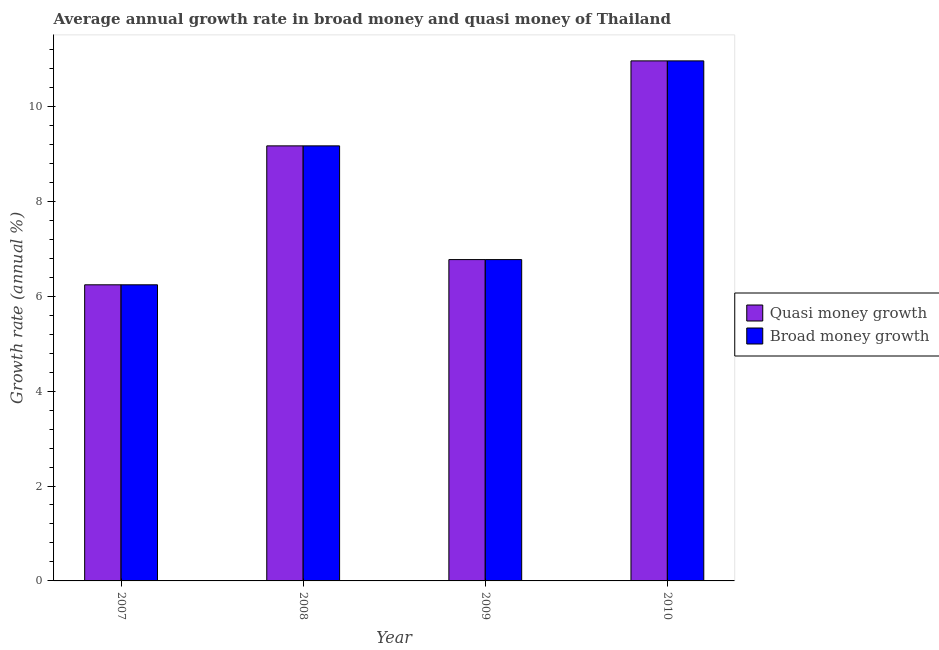How many different coloured bars are there?
Provide a succinct answer. 2. Are the number of bars on each tick of the X-axis equal?
Offer a terse response. Yes. In how many cases, is the number of bars for a given year not equal to the number of legend labels?
Your response must be concise. 0. What is the annual growth rate in broad money in 2008?
Keep it short and to the point. 9.17. Across all years, what is the maximum annual growth rate in quasi money?
Make the answer very short. 10.96. Across all years, what is the minimum annual growth rate in broad money?
Provide a short and direct response. 6.24. In which year was the annual growth rate in quasi money minimum?
Offer a terse response. 2007. What is the total annual growth rate in broad money in the graph?
Keep it short and to the point. 33.14. What is the difference between the annual growth rate in quasi money in 2007 and that in 2009?
Keep it short and to the point. -0.53. What is the difference between the annual growth rate in quasi money in 2008 and the annual growth rate in broad money in 2010?
Offer a terse response. -1.79. What is the average annual growth rate in quasi money per year?
Offer a terse response. 8.28. In the year 2009, what is the difference between the annual growth rate in broad money and annual growth rate in quasi money?
Offer a terse response. 0. In how many years, is the annual growth rate in quasi money greater than 3.6 %?
Offer a terse response. 4. What is the ratio of the annual growth rate in broad money in 2007 to that in 2009?
Keep it short and to the point. 0.92. What is the difference between the highest and the second highest annual growth rate in quasi money?
Offer a very short reply. 1.79. What is the difference between the highest and the lowest annual growth rate in broad money?
Your response must be concise. 4.72. In how many years, is the annual growth rate in quasi money greater than the average annual growth rate in quasi money taken over all years?
Your answer should be very brief. 2. Is the sum of the annual growth rate in quasi money in 2008 and 2010 greater than the maximum annual growth rate in broad money across all years?
Offer a very short reply. Yes. What does the 1st bar from the left in 2007 represents?
Keep it short and to the point. Quasi money growth. What does the 1st bar from the right in 2009 represents?
Your response must be concise. Broad money growth. Are the values on the major ticks of Y-axis written in scientific E-notation?
Make the answer very short. No. Does the graph contain grids?
Provide a short and direct response. No. How many legend labels are there?
Keep it short and to the point. 2. What is the title of the graph?
Offer a terse response. Average annual growth rate in broad money and quasi money of Thailand. Does "Commercial bank branches" appear as one of the legend labels in the graph?
Offer a very short reply. No. What is the label or title of the Y-axis?
Your response must be concise. Growth rate (annual %). What is the Growth rate (annual %) of Quasi money growth in 2007?
Ensure brevity in your answer.  6.24. What is the Growth rate (annual %) of Broad money growth in 2007?
Provide a succinct answer. 6.24. What is the Growth rate (annual %) in Quasi money growth in 2008?
Ensure brevity in your answer.  9.17. What is the Growth rate (annual %) of Broad money growth in 2008?
Your response must be concise. 9.17. What is the Growth rate (annual %) of Quasi money growth in 2009?
Your response must be concise. 6.77. What is the Growth rate (annual %) of Broad money growth in 2009?
Your response must be concise. 6.77. What is the Growth rate (annual %) of Quasi money growth in 2010?
Provide a short and direct response. 10.96. What is the Growth rate (annual %) of Broad money growth in 2010?
Offer a very short reply. 10.96. Across all years, what is the maximum Growth rate (annual %) in Quasi money growth?
Make the answer very short. 10.96. Across all years, what is the maximum Growth rate (annual %) of Broad money growth?
Make the answer very short. 10.96. Across all years, what is the minimum Growth rate (annual %) of Quasi money growth?
Offer a terse response. 6.24. Across all years, what is the minimum Growth rate (annual %) in Broad money growth?
Your answer should be very brief. 6.24. What is the total Growth rate (annual %) in Quasi money growth in the graph?
Give a very brief answer. 33.14. What is the total Growth rate (annual %) in Broad money growth in the graph?
Your response must be concise. 33.14. What is the difference between the Growth rate (annual %) of Quasi money growth in 2007 and that in 2008?
Your response must be concise. -2.93. What is the difference between the Growth rate (annual %) in Broad money growth in 2007 and that in 2008?
Give a very brief answer. -2.93. What is the difference between the Growth rate (annual %) in Quasi money growth in 2007 and that in 2009?
Your answer should be compact. -0.53. What is the difference between the Growth rate (annual %) in Broad money growth in 2007 and that in 2009?
Provide a short and direct response. -0.53. What is the difference between the Growth rate (annual %) in Quasi money growth in 2007 and that in 2010?
Provide a succinct answer. -4.72. What is the difference between the Growth rate (annual %) of Broad money growth in 2007 and that in 2010?
Provide a short and direct response. -4.72. What is the difference between the Growth rate (annual %) of Quasi money growth in 2008 and that in 2009?
Ensure brevity in your answer.  2.4. What is the difference between the Growth rate (annual %) in Broad money growth in 2008 and that in 2009?
Provide a succinct answer. 2.4. What is the difference between the Growth rate (annual %) in Quasi money growth in 2008 and that in 2010?
Ensure brevity in your answer.  -1.79. What is the difference between the Growth rate (annual %) in Broad money growth in 2008 and that in 2010?
Offer a terse response. -1.79. What is the difference between the Growth rate (annual %) of Quasi money growth in 2009 and that in 2010?
Offer a very short reply. -4.19. What is the difference between the Growth rate (annual %) in Broad money growth in 2009 and that in 2010?
Ensure brevity in your answer.  -4.19. What is the difference between the Growth rate (annual %) in Quasi money growth in 2007 and the Growth rate (annual %) in Broad money growth in 2008?
Offer a very short reply. -2.93. What is the difference between the Growth rate (annual %) in Quasi money growth in 2007 and the Growth rate (annual %) in Broad money growth in 2009?
Offer a very short reply. -0.53. What is the difference between the Growth rate (annual %) of Quasi money growth in 2007 and the Growth rate (annual %) of Broad money growth in 2010?
Offer a terse response. -4.72. What is the difference between the Growth rate (annual %) of Quasi money growth in 2008 and the Growth rate (annual %) of Broad money growth in 2009?
Your answer should be very brief. 2.4. What is the difference between the Growth rate (annual %) in Quasi money growth in 2008 and the Growth rate (annual %) in Broad money growth in 2010?
Keep it short and to the point. -1.79. What is the difference between the Growth rate (annual %) in Quasi money growth in 2009 and the Growth rate (annual %) in Broad money growth in 2010?
Make the answer very short. -4.19. What is the average Growth rate (annual %) of Quasi money growth per year?
Keep it short and to the point. 8.28. What is the average Growth rate (annual %) of Broad money growth per year?
Your answer should be very brief. 8.28. In the year 2007, what is the difference between the Growth rate (annual %) of Quasi money growth and Growth rate (annual %) of Broad money growth?
Ensure brevity in your answer.  0. What is the ratio of the Growth rate (annual %) in Quasi money growth in 2007 to that in 2008?
Ensure brevity in your answer.  0.68. What is the ratio of the Growth rate (annual %) of Broad money growth in 2007 to that in 2008?
Provide a succinct answer. 0.68. What is the ratio of the Growth rate (annual %) of Quasi money growth in 2007 to that in 2009?
Give a very brief answer. 0.92. What is the ratio of the Growth rate (annual %) of Broad money growth in 2007 to that in 2009?
Give a very brief answer. 0.92. What is the ratio of the Growth rate (annual %) of Quasi money growth in 2007 to that in 2010?
Provide a succinct answer. 0.57. What is the ratio of the Growth rate (annual %) in Broad money growth in 2007 to that in 2010?
Provide a short and direct response. 0.57. What is the ratio of the Growth rate (annual %) of Quasi money growth in 2008 to that in 2009?
Provide a short and direct response. 1.35. What is the ratio of the Growth rate (annual %) of Broad money growth in 2008 to that in 2009?
Offer a terse response. 1.35. What is the ratio of the Growth rate (annual %) of Quasi money growth in 2008 to that in 2010?
Offer a very short reply. 0.84. What is the ratio of the Growth rate (annual %) in Broad money growth in 2008 to that in 2010?
Make the answer very short. 0.84. What is the ratio of the Growth rate (annual %) of Quasi money growth in 2009 to that in 2010?
Offer a very short reply. 0.62. What is the ratio of the Growth rate (annual %) of Broad money growth in 2009 to that in 2010?
Keep it short and to the point. 0.62. What is the difference between the highest and the second highest Growth rate (annual %) of Quasi money growth?
Provide a succinct answer. 1.79. What is the difference between the highest and the second highest Growth rate (annual %) of Broad money growth?
Provide a succinct answer. 1.79. What is the difference between the highest and the lowest Growth rate (annual %) of Quasi money growth?
Make the answer very short. 4.72. What is the difference between the highest and the lowest Growth rate (annual %) of Broad money growth?
Give a very brief answer. 4.72. 